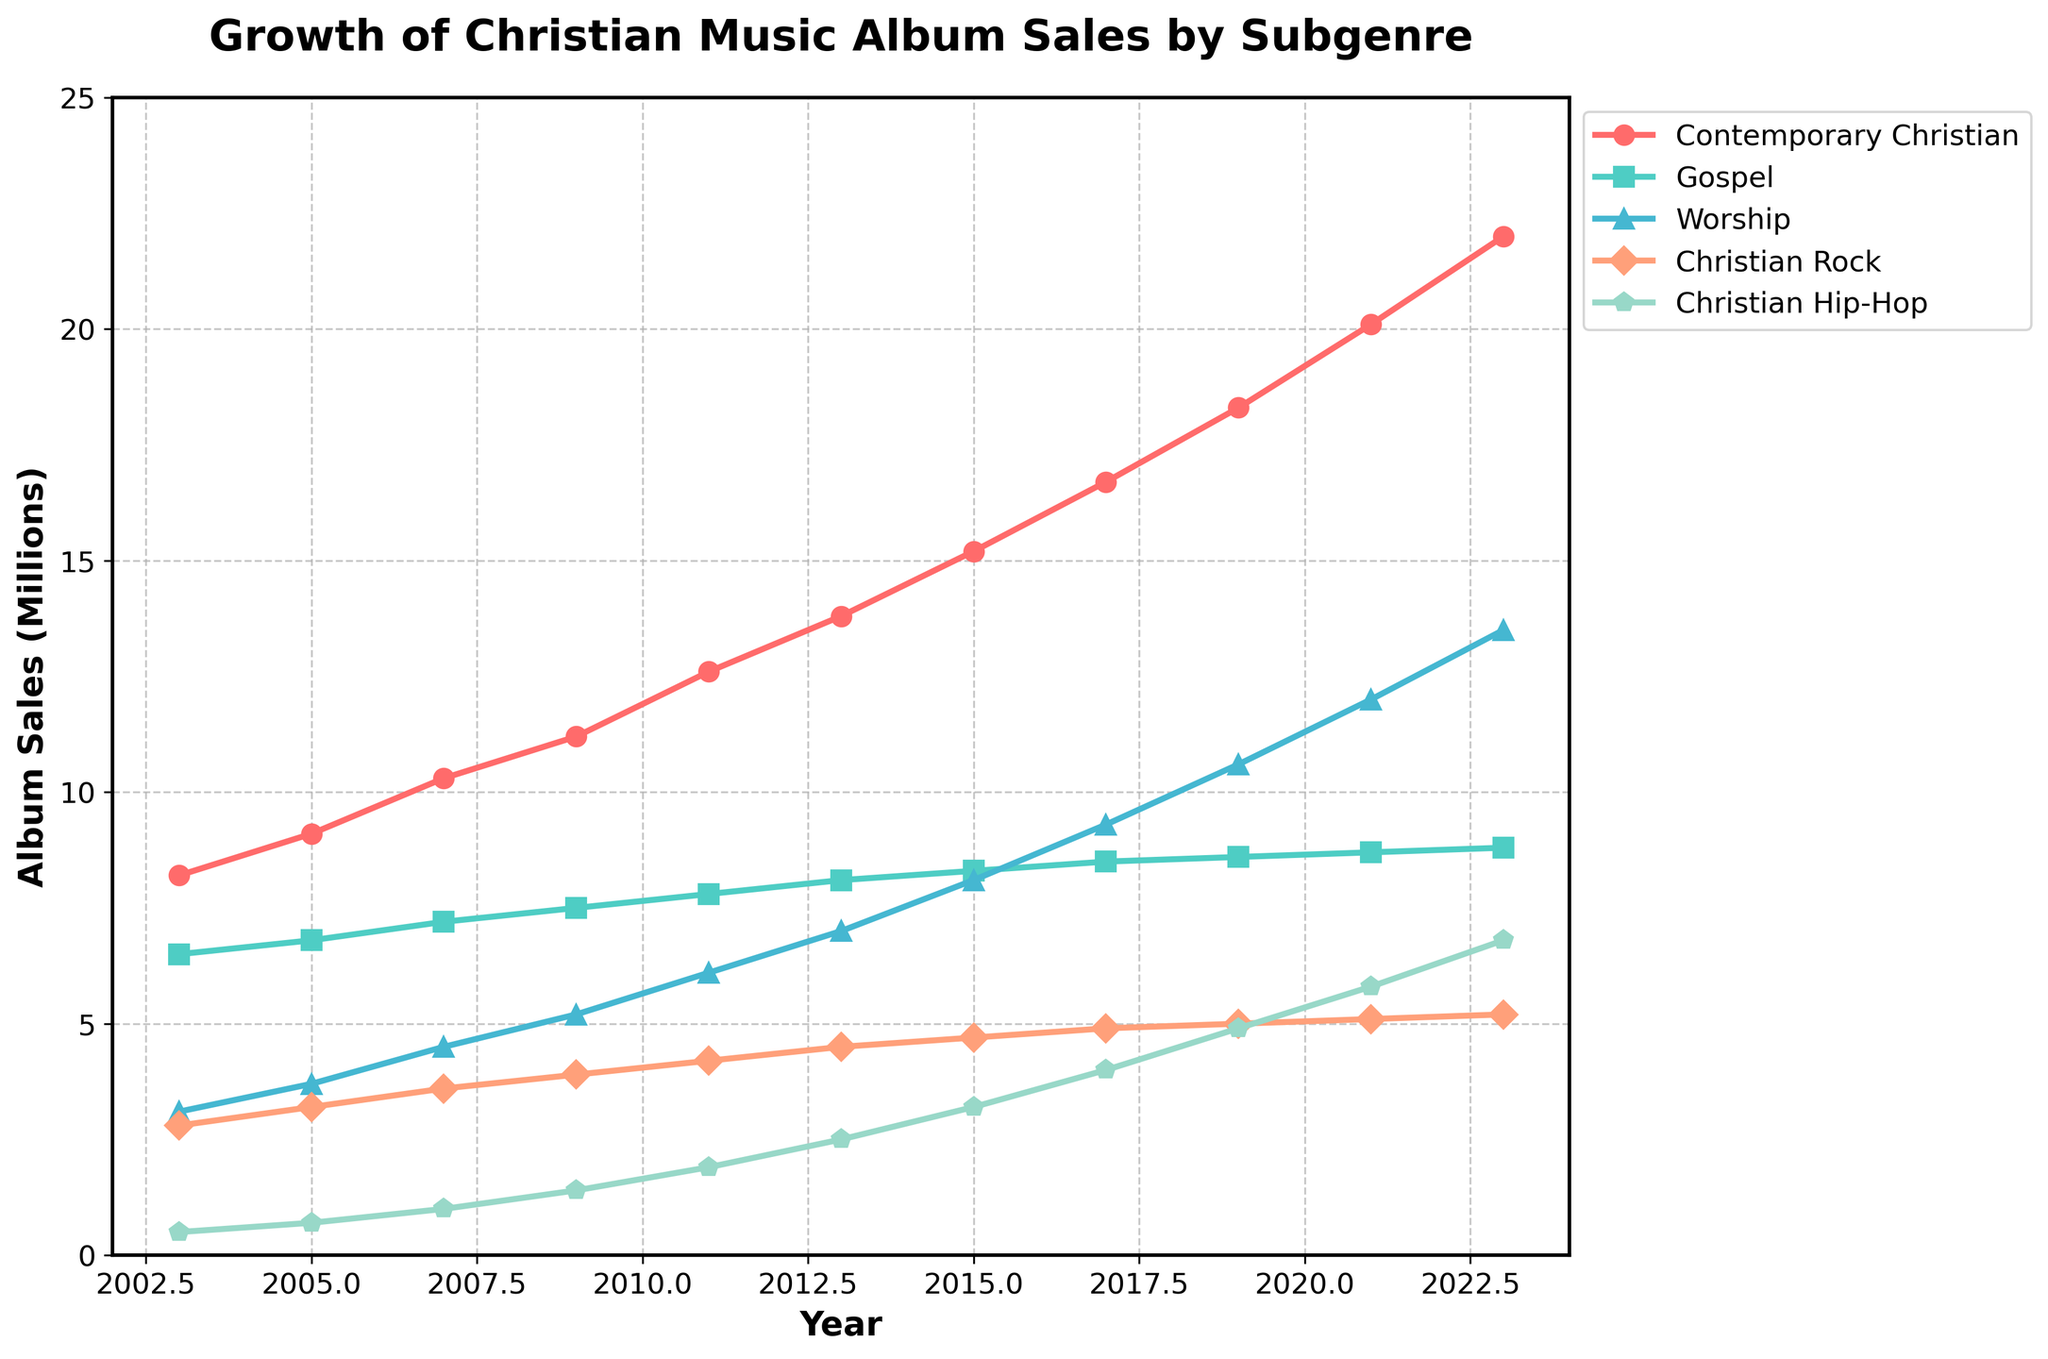What year did Contemporary Christian album sales surpass 15 million? Looking at the growth of Contemporary Christian album sales, the trend surpasses 15 million in 2015.
Answer: 2015 Which subgenre had the highest album sales in 2023? In 2023, Contemporary Christian had the highest sales, reaching 22 million albums sold.
Answer: Contemporary Christian By how much did Christian Hip-Hop sales increase between 2003 and 2023? Subtract the Christian Hip-Hop sales in 2003 (0.5 million) from the sales in 2023 (6.8 million). The increase is 6.8 - 0.5 = 6.3 million.
Answer: 6.3 million Comparing Gospel and Worship sales in 2017, which subgenre sold more albums and by how much? Gospel sales in 2017 were 8.5 million, while Worship sales were 9.3 million. Worship sold 0.8 million more albums than Gospel.
Answer: Worship, 0.8 million What is the average annual growth of Worship album sales from 2003 to 2023? Calculate the increase in Worship sales over the years: 13.5 (2023) - 3.1 (2003) = 10.4 million. Then divide by the number of years (2023 - 2003 = 20 years): 10.4 / 20 = 0.52 million per year.
Answer: 0.52 million per year Which subgenre had the least growth in sales over the two decades? Calculate the growth for each subgenre: Contemporary Christian (22.0 - 8.2 = 13.8 million), Gospel (8.8 - 6.5 = 2.3 million), Worship (13.5 - 3.1 = 10.4 million), Christian Rock (5.2 - 2.8 = 2.4 million), Christian Hip-Hop (6.8 - 0.5 = 6.3 million). Gospel had the least growth at 2.3 million.
Answer: Gospel During which five-year period did Christian Rock sales grow the most? Check the increments for every five-year period: 2003-2008 (0.8 million), 2008-2013 (0.6 million), 2013-2018 (0.2 million), 2018-2023 (0.2 million). The largest growth was from 2003 to 2008 with an increment of 0.8 million.
Answer: 2003 to 2008 Identify the subgenre whose sales doubled or more between 2003 and 2023. Comparing 2023 sales to 2003 sales for each subgenre: Contemporary Christian (22.0 million / 8.2 million), Gospel (8.8 million / 6.5 million), Worship (13.5 million / 3.1 million), Christian Rock (5.2 million / 2.8 million), Christian Hip-Hop (6.8 million / 0.5 million). Only Worship and Christian Hip-Hop showed sales more than doubled.
Answer: Worship, Christian Hip-Hop How many years did it take for Contemporary Christian sales to increase from 10 million to 20 million? Contemporary Christian sales were 10.3 million in 2007 and 20.1 million in 2021. Therefore, it took 2021 - 2007 = 14 years.
Answer: 14 years 